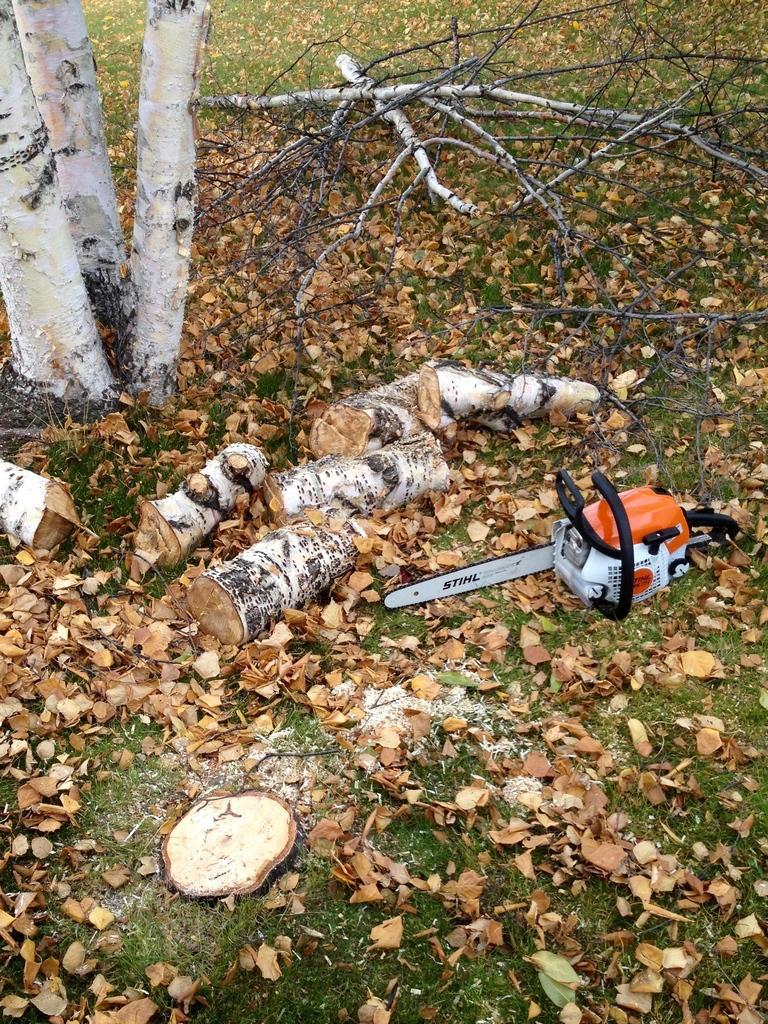Can you describe this image briefly? In this picture we can see an object on the ground and in the background we can see tree branches and leaves. 